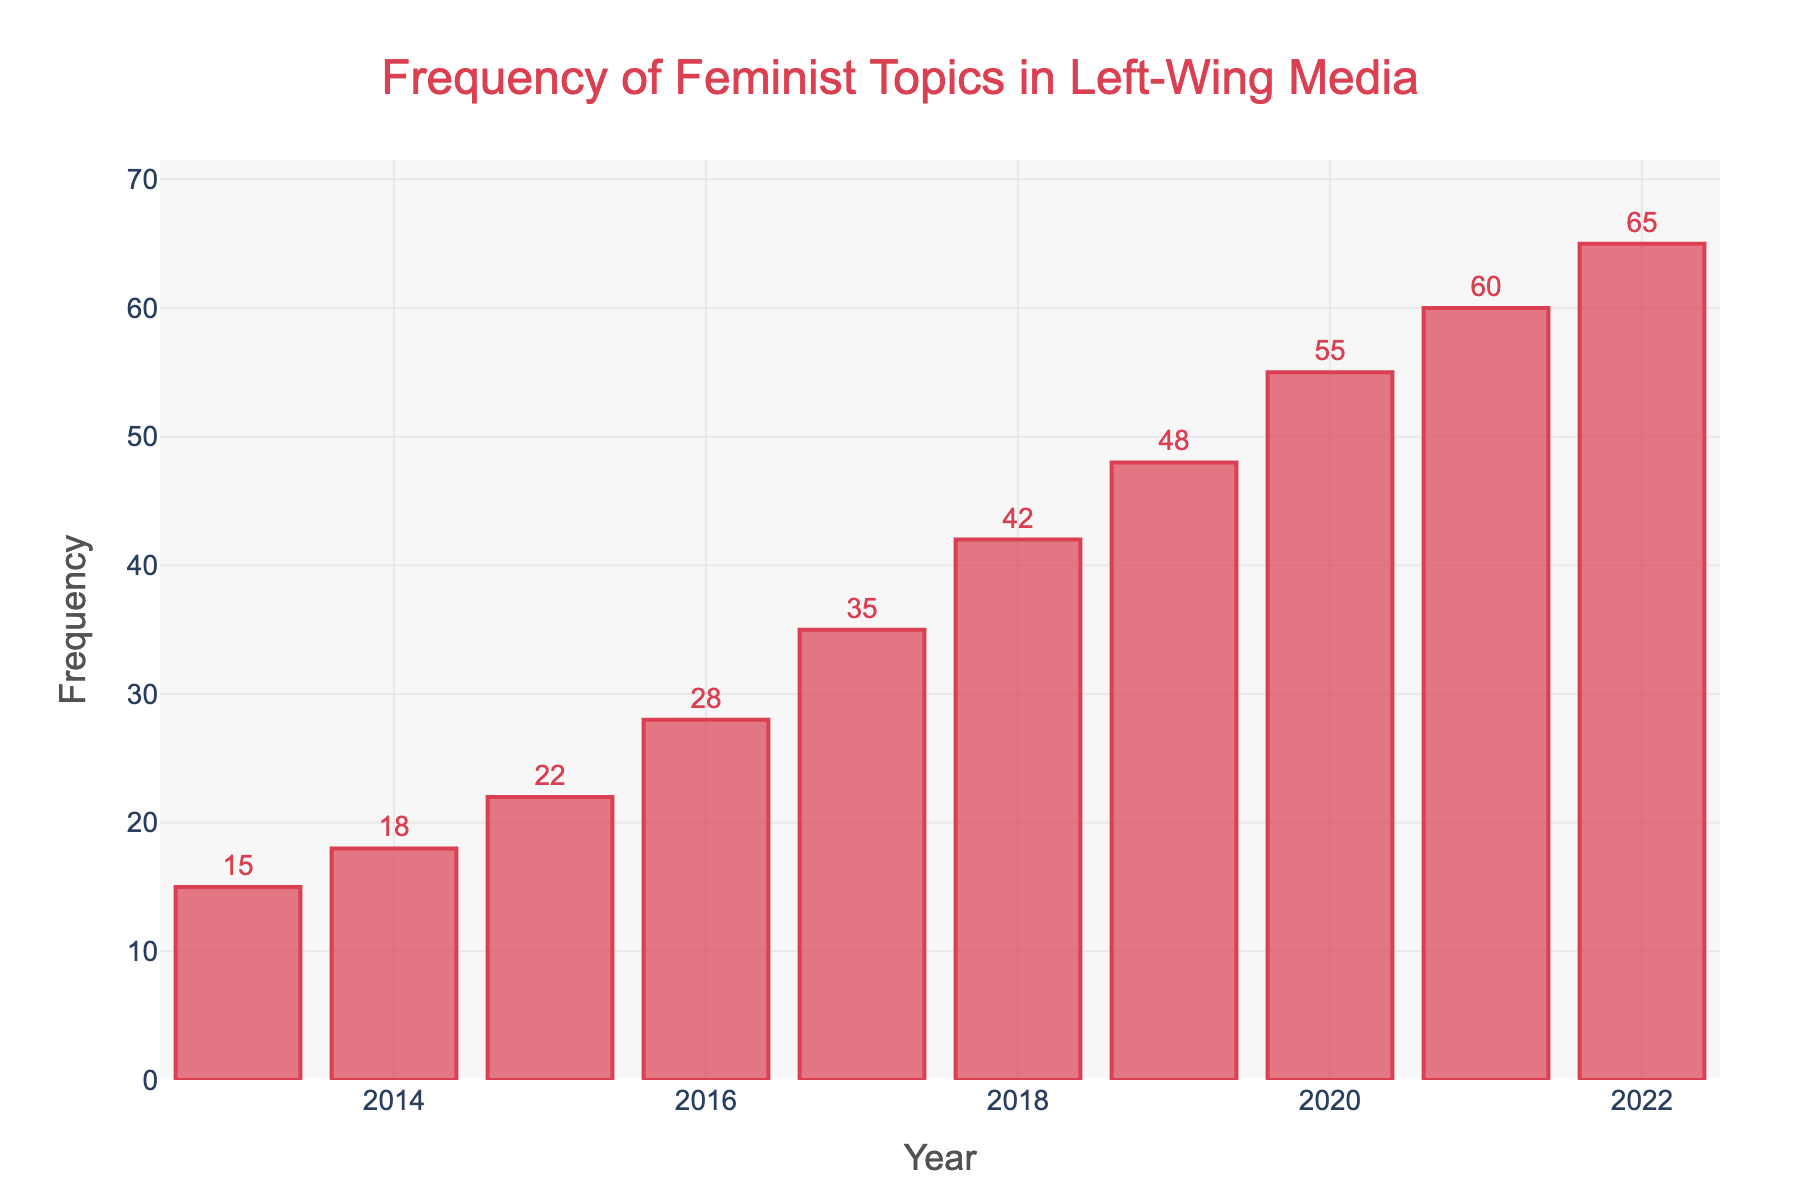What is the frequency of feminist topics discussed in 2016? To find the frequency of feminist topics discussed in 2016, look at the bar corresponding to the year 2016 on the x-axis, and then observe its height which represents the frequency on the y-axis.
Answer: 28 By how much did the frequency increase from 2013 to 2017? First, identify the frequency values for 2013 and 2017 from the chart. For 2013, the frequency is 15, and for 2017, it is 35. Subtract the 2013 value from the 2017 value: 35 - 15 = 20.
Answer: 20 Which year had the highest frequency of feminist topics discussed? Look for the tallest bar in the chart, which represents the highest frequency. The tallest bar corresponds to the year 2022.
Answer: 2022 How many times did the frequency increase by more than 10 units compared to the previous year? Compare the frequencies year-over-year to see the increments. From the data: 2013 to 2014 (3), 2014 to 2015 (4), 2015 to 2016 (6), 2016 to 2017 (7), 2017 to 2018 (7), 2018 to 2019 (6), 2019 to 2020 (7), 2020 to 2021 (5), and 2021 to 2022 (5). All increments are less than or equal to 10, so 0 times.
Answer: 0 What is the average frequency of feminist topics discussed between 2013 and 2022? Sum the frequencies from 2013 to 2022 and divide by the number of years (10). Sum is 15 + 18 + 22 + 28 + 35 + 42 + 48 + 55 + 60 + 65 = 388. Average is 388 / 10 = 38.8.
Answer: 38.8 How does the frequency of feminist topics discussed in 2020 compare to 2018? Identify the frequencies for 2020 and 2018. For 2020, the frequency is 55 and for 2018, it is 42. The frequency in 2020 is higher by 55 - 42 = 13 units.
Answer: 13 units higher What was the total increase in frequency of feminist topics from 2013 to 2022? Subtract the frequency in 2013 from the frequency in 2022. The values are 65 (2022) and 15 (2013). The total increase is 65 - 15 = 50.
Answer: 50 Describe the visual change in the frequency bars from 2013 to 2022. The bars increase in height as you move from 2013 to 2022, with each subsequent bar generally higher than the previous one, indicating a steady rise in the frequency of feminist topics discussed over the period.
Answer: Steady rise In which year did the frequency first exceed 40? Look at the bars sequentially until you find the first year where the frequency bar exceeds the 40 mark on the y-axis. This occurs in 2018.
Answer: 2018 